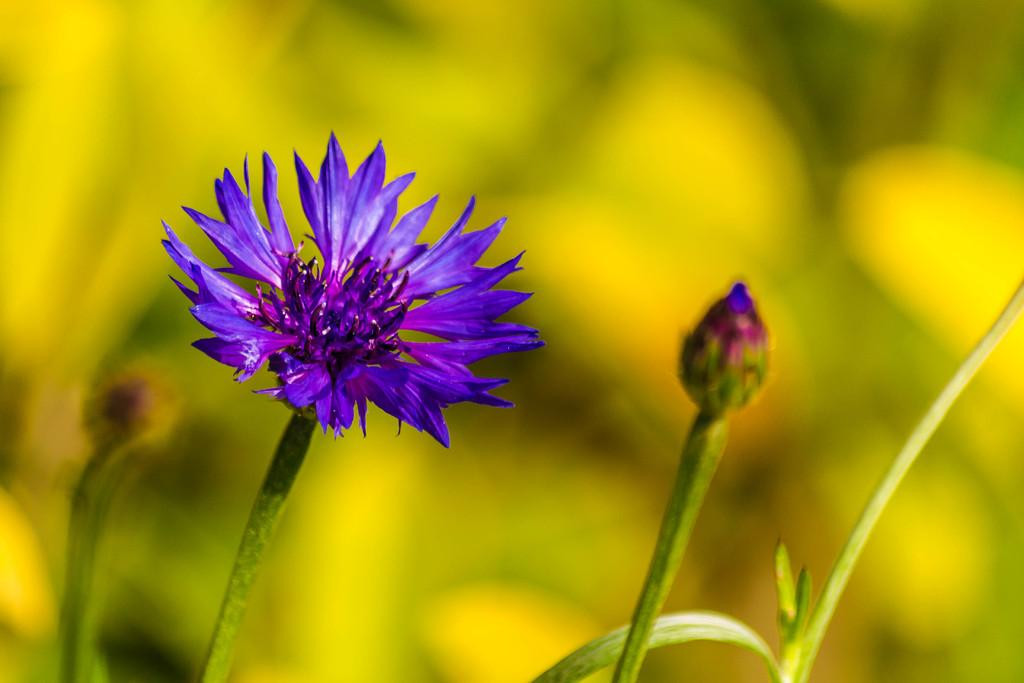What type of plant can be seen in the image? There is a flower in the image. Can you describe the stage of the flower in the image? There is a bud in the image. What connects the flower and the bud in the image? There is a stem in the image. What is the appearance of the background in the image? The background of the image is blurred. What type of fabric can be seen on the skirt in the image? There is no skirt present in the image; it features a flower, a bud, and a stem. 